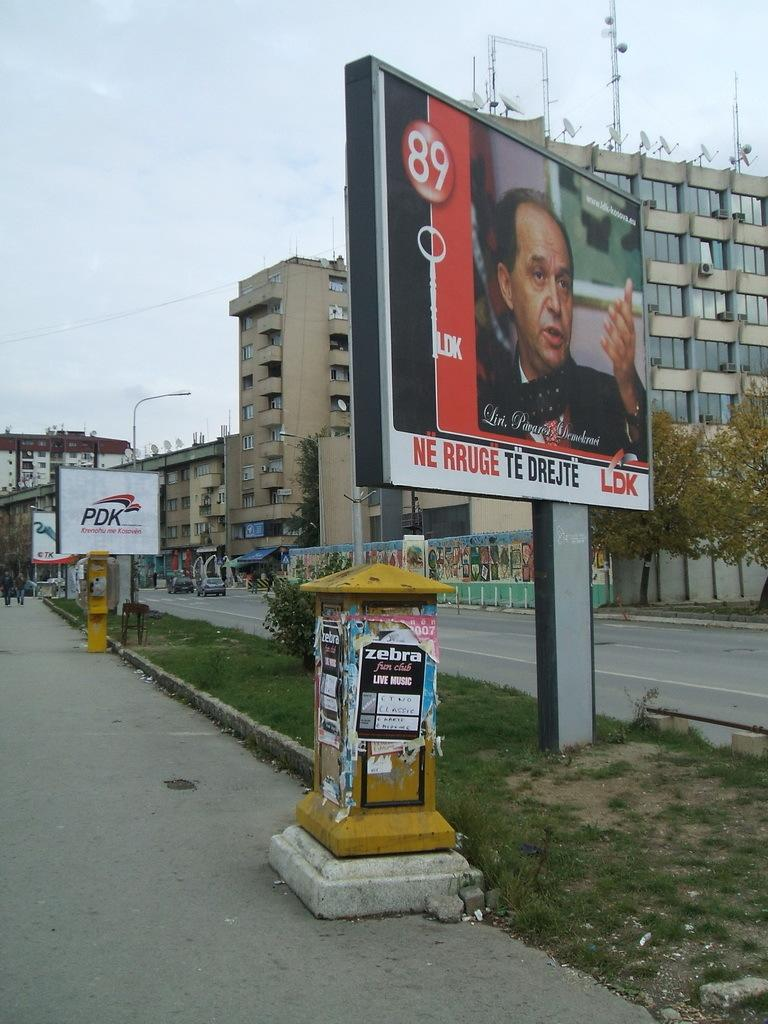<image>
Write a terse but informative summary of the picture. A yellow post is covered in posters with one reading Zebra Fun Club 